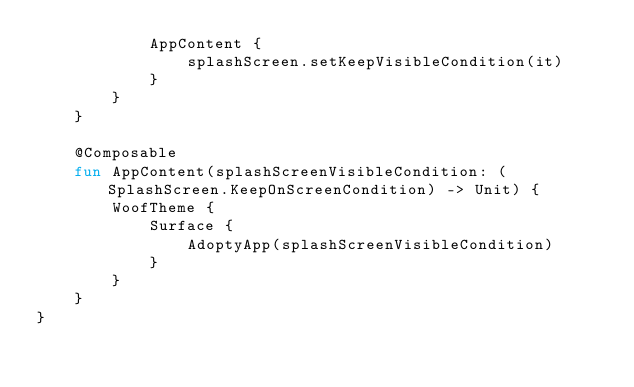<code> <loc_0><loc_0><loc_500><loc_500><_Kotlin_>            AppContent {
                splashScreen.setKeepVisibleCondition(it)
            }
        }
    }

    @Composable
    fun AppContent(splashScreenVisibleCondition: (SplashScreen.KeepOnScreenCondition) -> Unit) {
        WoofTheme {
            Surface {
                AdoptyApp(splashScreenVisibleCondition)
            }
        }
    }
}
</code> 